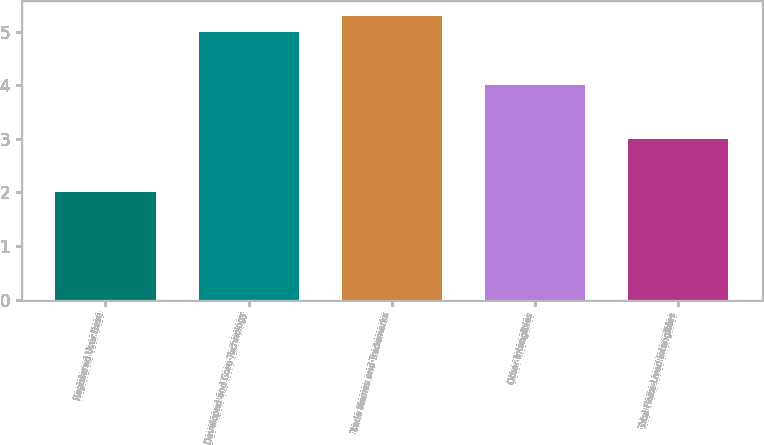Convert chart to OTSL. <chart><loc_0><loc_0><loc_500><loc_500><bar_chart><fcel>Registered User Base<fcel>Developed and Core Technology<fcel>Trade Names and Trademarks<fcel>Other Intangibles<fcel>Total Finite-Lived Intangibles<nl><fcel>2<fcel>5<fcel>5.3<fcel>4<fcel>3<nl></chart> 